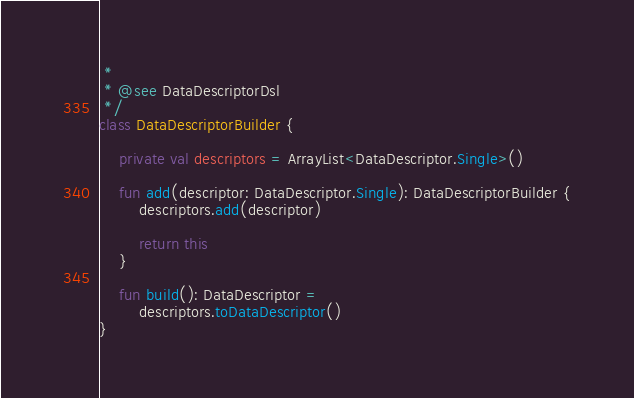<code> <loc_0><loc_0><loc_500><loc_500><_Kotlin_> *
 * @see DataDescriptorDsl
 */
class DataDescriptorBuilder {

    private val descriptors = ArrayList<DataDescriptor.Single>()

    fun add(descriptor: DataDescriptor.Single): DataDescriptorBuilder {
        descriptors.add(descriptor)

        return this
    }

    fun build(): DataDescriptor =
        descriptors.toDataDescriptor()
}</code> 